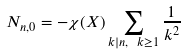Convert formula to latex. <formula><loc_0><loc_0><loc_500><loc_500>N _ { n , 0 } = - \chi ( X ) \sum _ { k | n , \ k \geq 1 } \frac { 1 } { k ^ { 2 } }</formula> 